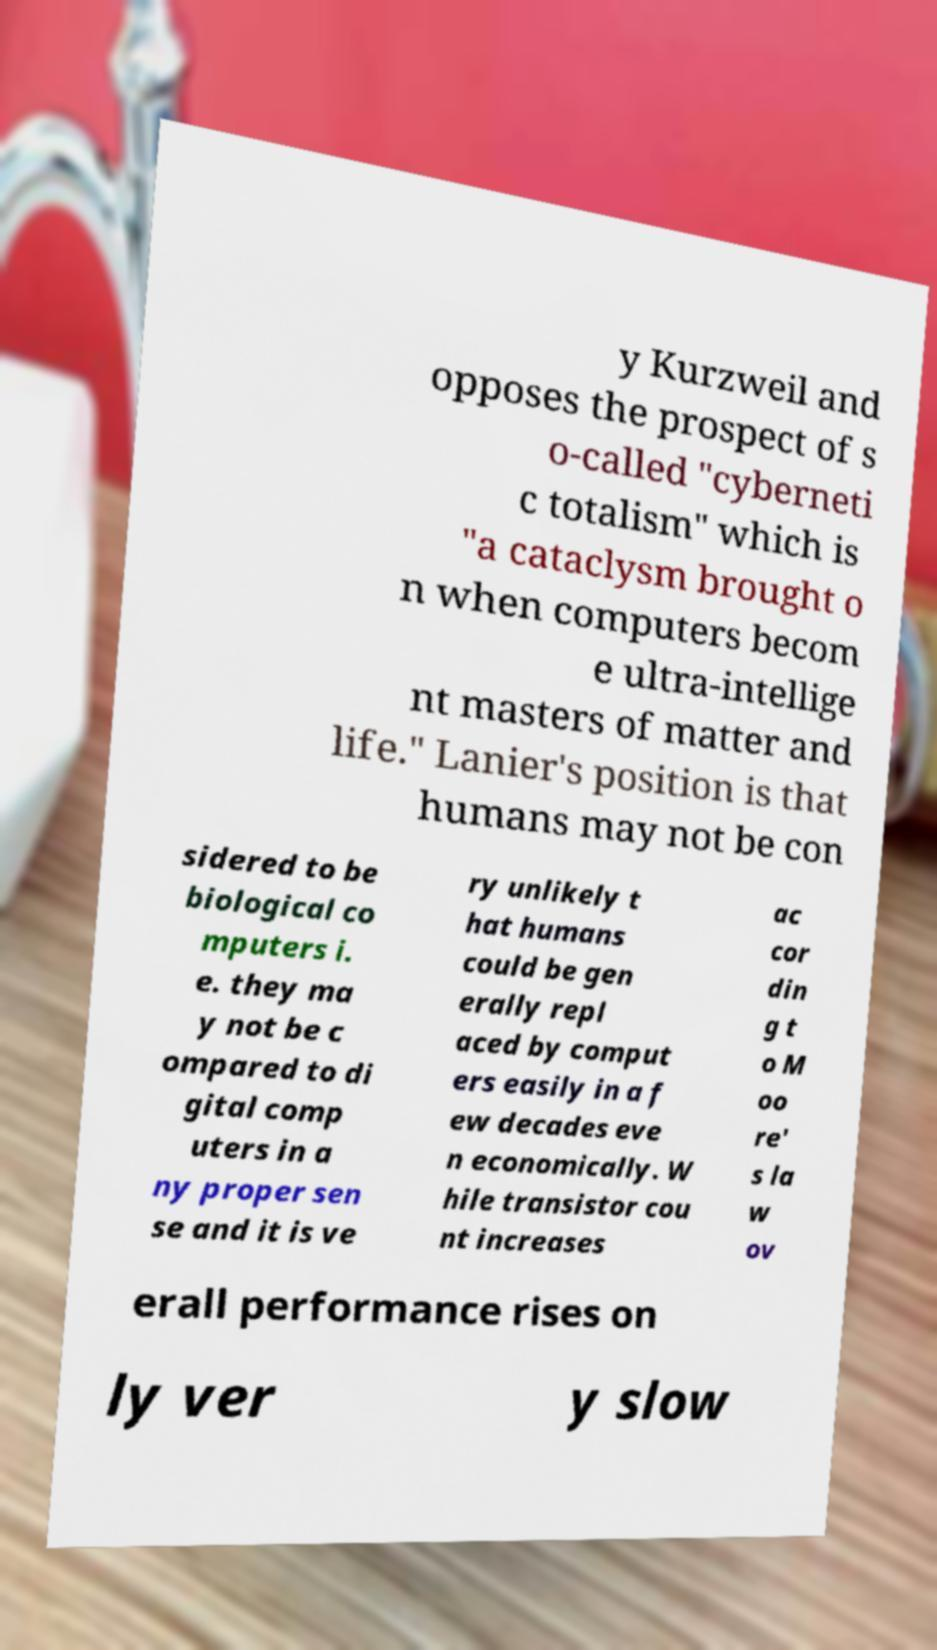Please read and relay the text visible in this image. What does it say? y Kurzweil and opposes the prospect of s o-called "cyberneti c totalism" which is "a cataclysm brought o n when computers becom e ultra-intellige nt masters of matter and life." Lanier's position is that humans may not be con sidered to be biological co mputers i. e. they ma y not be c ompared to di gital comp uters in a ny proper sen se and it is ve ry unlikely t hat humans could be gen erally repl aced by comput ers easily in a f ew decades eve n economically. W hile transistor cou nt increases ac cor din g t o M oo re' s la w ov erall performance rises on ly ver y slow 